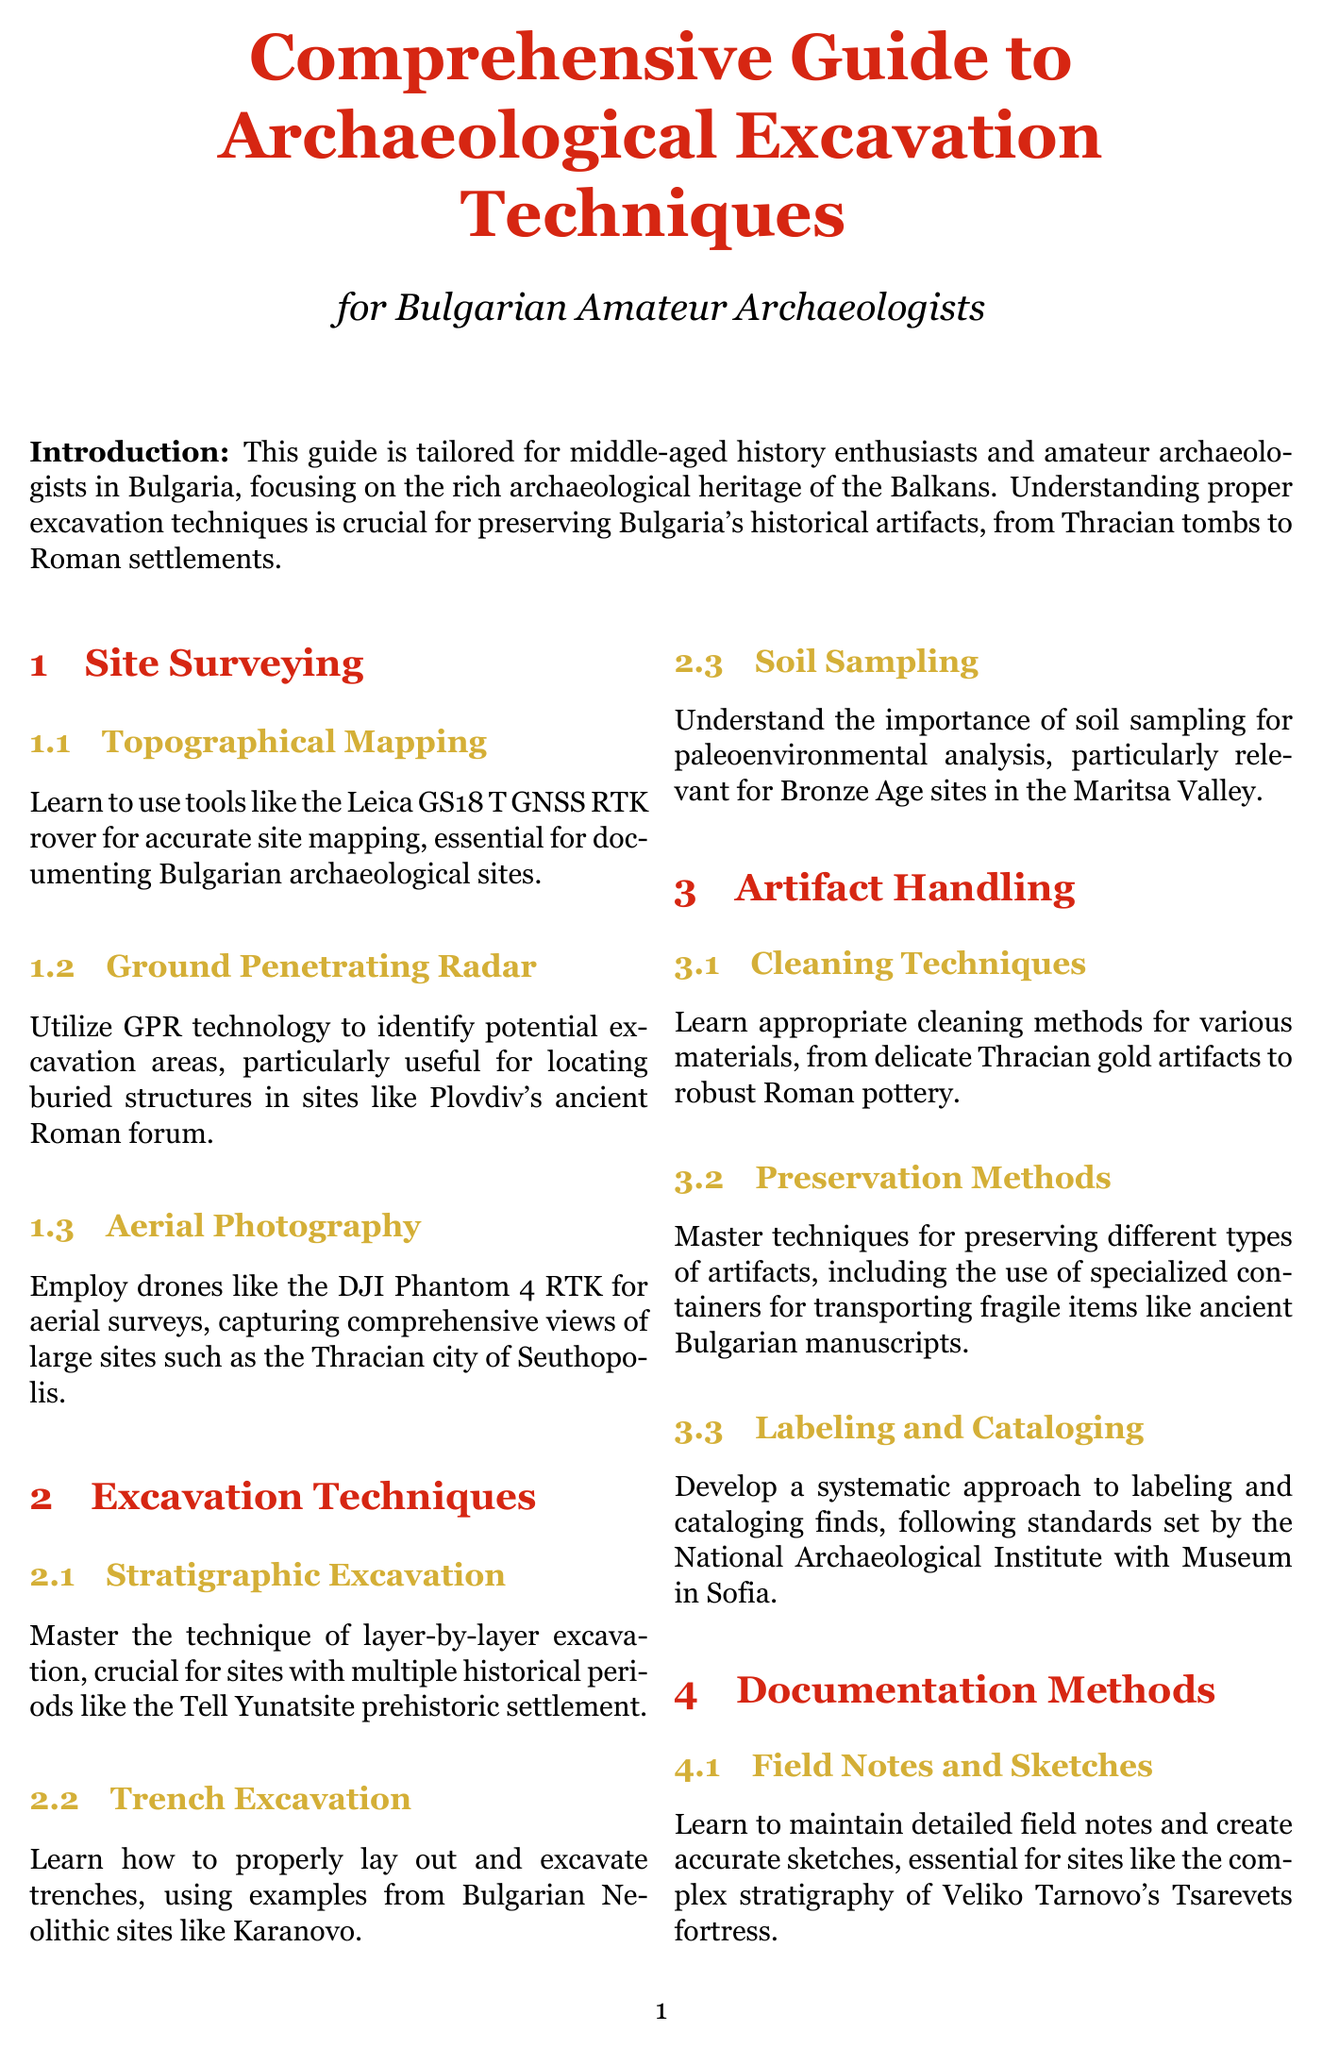What is the title of the manual? The title of the manual is stated at the beginning of the document, which is focused on archaeological excavation techniques.
Answer: Comprehensive Guide to Archaeological Excavation Techniques for Bulgarian Amateur Archaeologists What technology is recommended for topographical mapping? The document specifies a tool for accurate site mapping in the topographical mapping section.
Answer: Leica GS18 T GNSS RTK rover What excavation technique is crucial for multiple historical periods? The document mentions a specific excavation technique relevant to sites with various historical layers in the excavation techniques chapter.
Answer: Stratigraphic Excavation Which drone is suggested for aerial photography? A specific drone model is mentioned in the aerial photography section for conducting aerial surveys.
Answer: DJI Phantom 4 RTK What is the legal framework governing archaeological activities in Bulgaria? The document provides a reference to the laws that govern archaeology in Bulgaria within the legal and ethical considerations section.
Answer: Cultural Heritage Act of 2009 What two aspects are involved in handling artifacts? The document highlights specific practices for cleaning and preserving artifacts in the artifact handling section.
Answer: Cleaning Techniques and Preservation Methods What software is recommended for 3D modeling? A specific software for creating 3D models is mentioned in the documentation methods section of the document.
Answer: Agisoft Metashape Who should amateur archaeologists collaborate with? The document advises collaboration with a particular group of professionals in its legal and ethical considerations chapter.
Answer: Professional archaeologists What method is essential for documenting finds? The document emphasizes a specific technique crucial for reliably documenting archaeological finds within the documentation methods section.
Answer: Archaeological photography techniques 